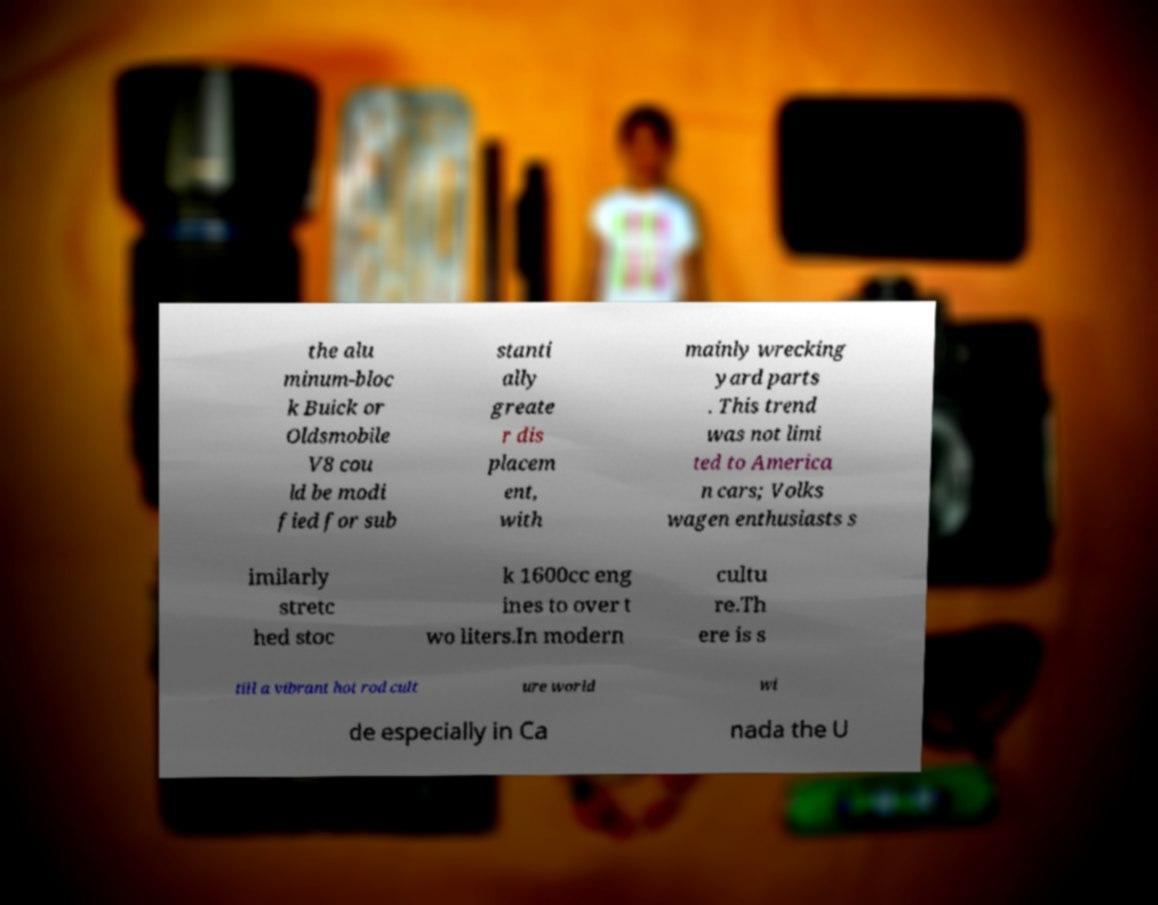Can you accurately transcribe the text from the provided image for me? the alu minum-bloc k Buick or Oldsmobile V8 cou ld be modi fied for sub stanti ally greate r dis placem ent, with mainly wrecking yard parts . This trend was not limi ted to America n cars; Volks wagen enthusiasts s imilarly stretc hed stoc k 1600cc eng ines to over t wo liters.In modern cultu re.Th ere is s till a vibrant hot rod cult ure world wi de especially in Ca nada the U 